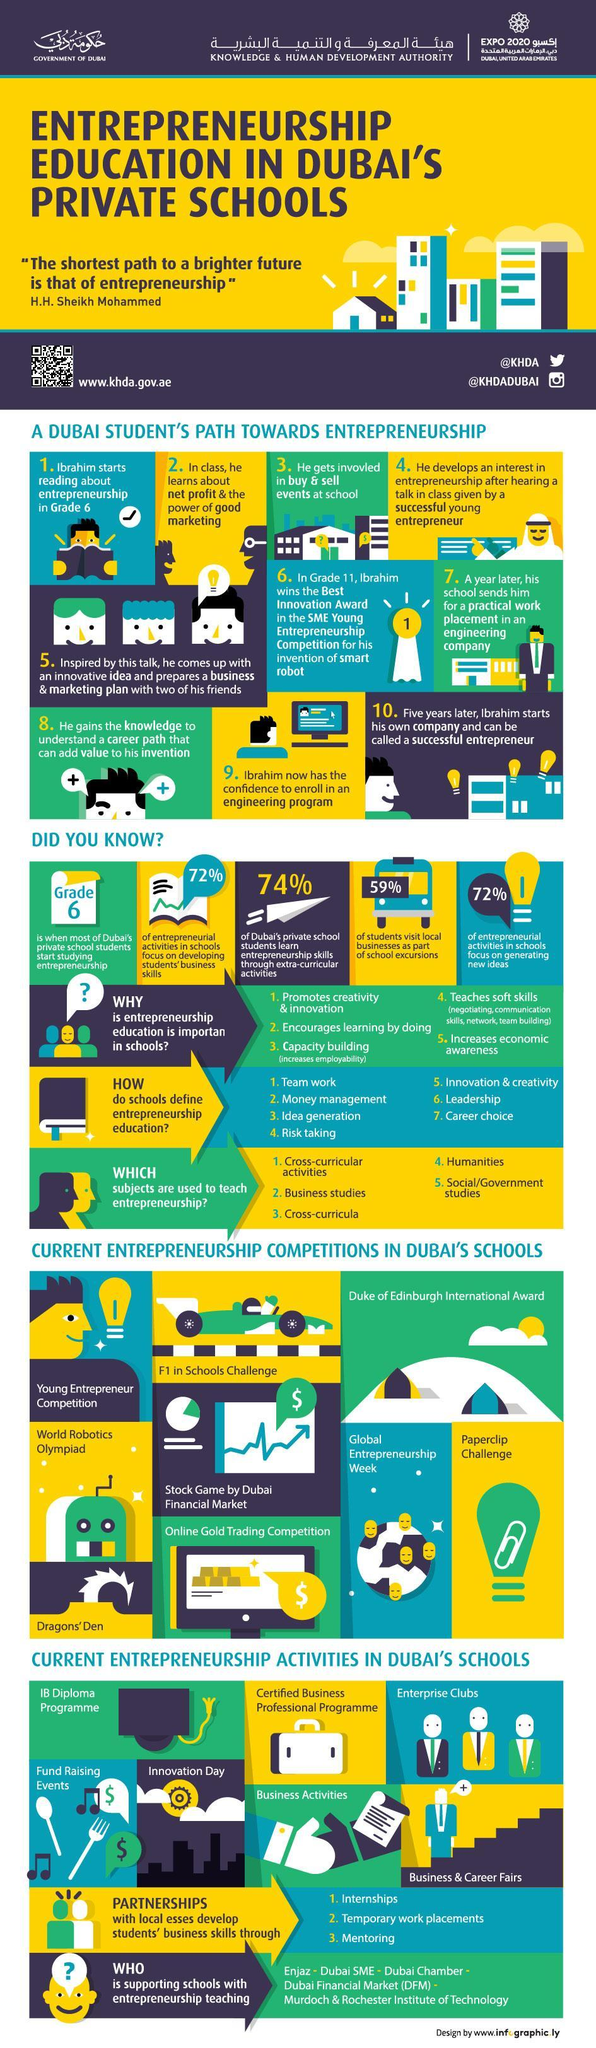What percentage of entrepreneurial activities in schools focus on generating new ideas?
Answer the question with a short phrase. 72% What percentage of students visit local businesses as part of school excursions in Dubai? 59% What percentage of Dubai's private school students learn entrepreneurship skills through extra-curricular activities? 74% In which grade, most of Dubai's private school students start studying entrepreneurship? Grade 6 